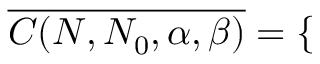Convert formula to latex. <formula><loc_0><loc_0><loc_500><loc_500>\overline { { C ( N , N _ { 0 } , \alpha , \beta ) } } = \left \{ \begin{array} { r l } \end{array}</formula> 